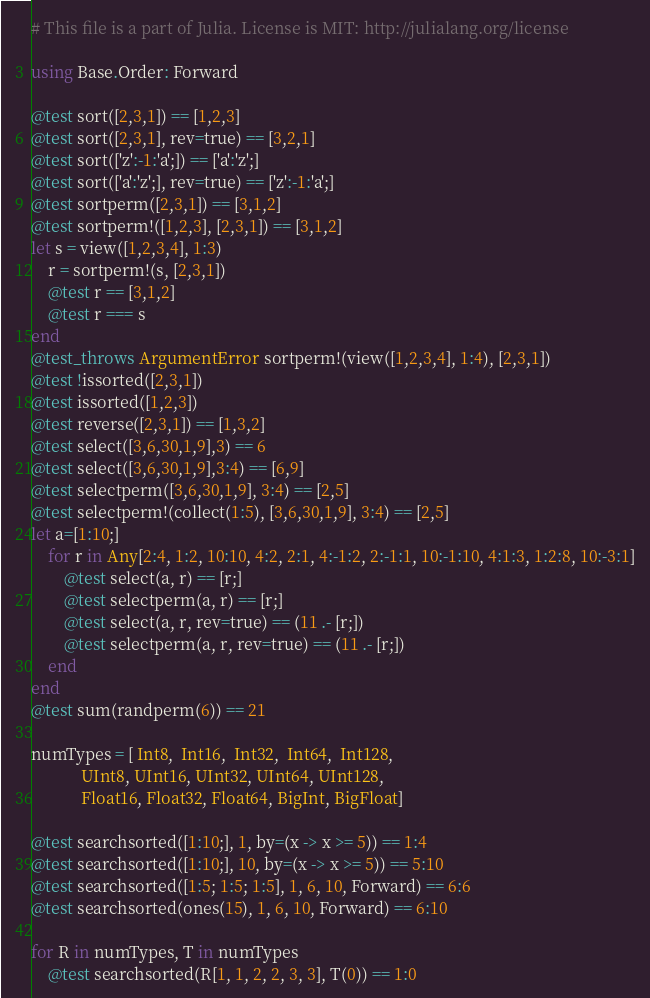Convert code to text. <code><loc_0><loc_0><loc_500><loc_500><_Julia_># This file is a part of Julia. License is MIT: http://julialang.org/license

using Base.Order: Forward

@test sort([2,3,1]) == [1,2,3]
@test sort([2,3,1], rev=true) == [3,2,1]
@test sort(['z':-1:'a';]) == ['a':'z';]
@test sort(['a':'z';], rev=true) == ['z':-1:'a';]
@test sortperm([2,3,1]) == [3,1,2]
@test sortperm!([1,2,3], [2,3,1]) == [3,1,2]
let s = view([1,2,3,4], 1:3)
    r = sortperm!(s, [2,3,1])
    @test r == [3,1,2]
    @test r === s
end
@test_throws ArgumentError sortperm!(view([1,2,3,4], 1:4), [2,3,1])
@test !issorted([2,3,1])
@test issorted([1,2,3])
@test reverse([2,3,1]) == [1,3,2]
@test select([3,6,30,1,9],3) == 6
@test select([3,6,30,1,9],3:4) == [6,9]
@test selectperm([3,6,30,1,9], 3:4) == [2,5]
@test selectperm!(collect(1:5), [3,6,30,1,9], 3:4) == [2,5]
let a=[1:10;]
    for r in Any[2:4, 1:2, 10:10, 4:2, 2:1, 4:-1:2, 2:-1:1, 10:-1:10, 4:1:3, 1:2:8, 10:-3:1]
        @test select(a, r) == [r;]
        @test selectperm(a, r) == [r;]
        @test select(a, r, rev=true) == (11 .- [r;])
        @test selectperm(a, r, rev=true) == (11 .- [r;])
    end
end
@test sum(randperm(6)) == 21

numTypes = [ Int8,  Int16,  Int32,  Int64,  Int128,
            UInt8, UInt16, UInt32, UInt64, UInt128,
            Float16, Float32, Float64, BigInt, BigFloat]

@test searchsorted([1:10;], 1, by=(x -> x >= 5)) == 1:4
@test searchsorted([1:10;], 10, by=(x -> x >= 5)) == 5:10
@test searchsorted([1:5; 1:5; 1:5], 1, 6, 10, Forward) == 6:6
@test searchsorted(ones(15), 1, 6, 10, Forward) == 6:10

for R in numTypes, T in numTypes
    @test searchsorted(R[1, 1, 2, 2, 3, 3], T(0)) == 1:0</code> 